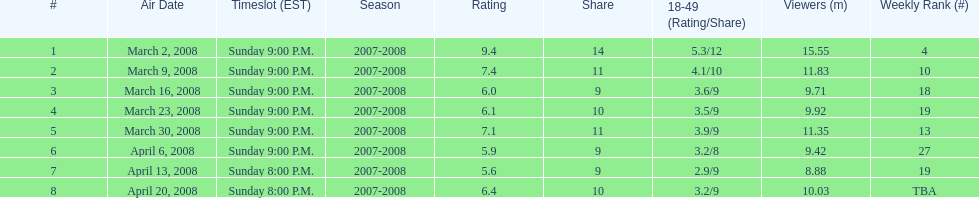When was the air date with the smallest audience? April 13, 2008. 